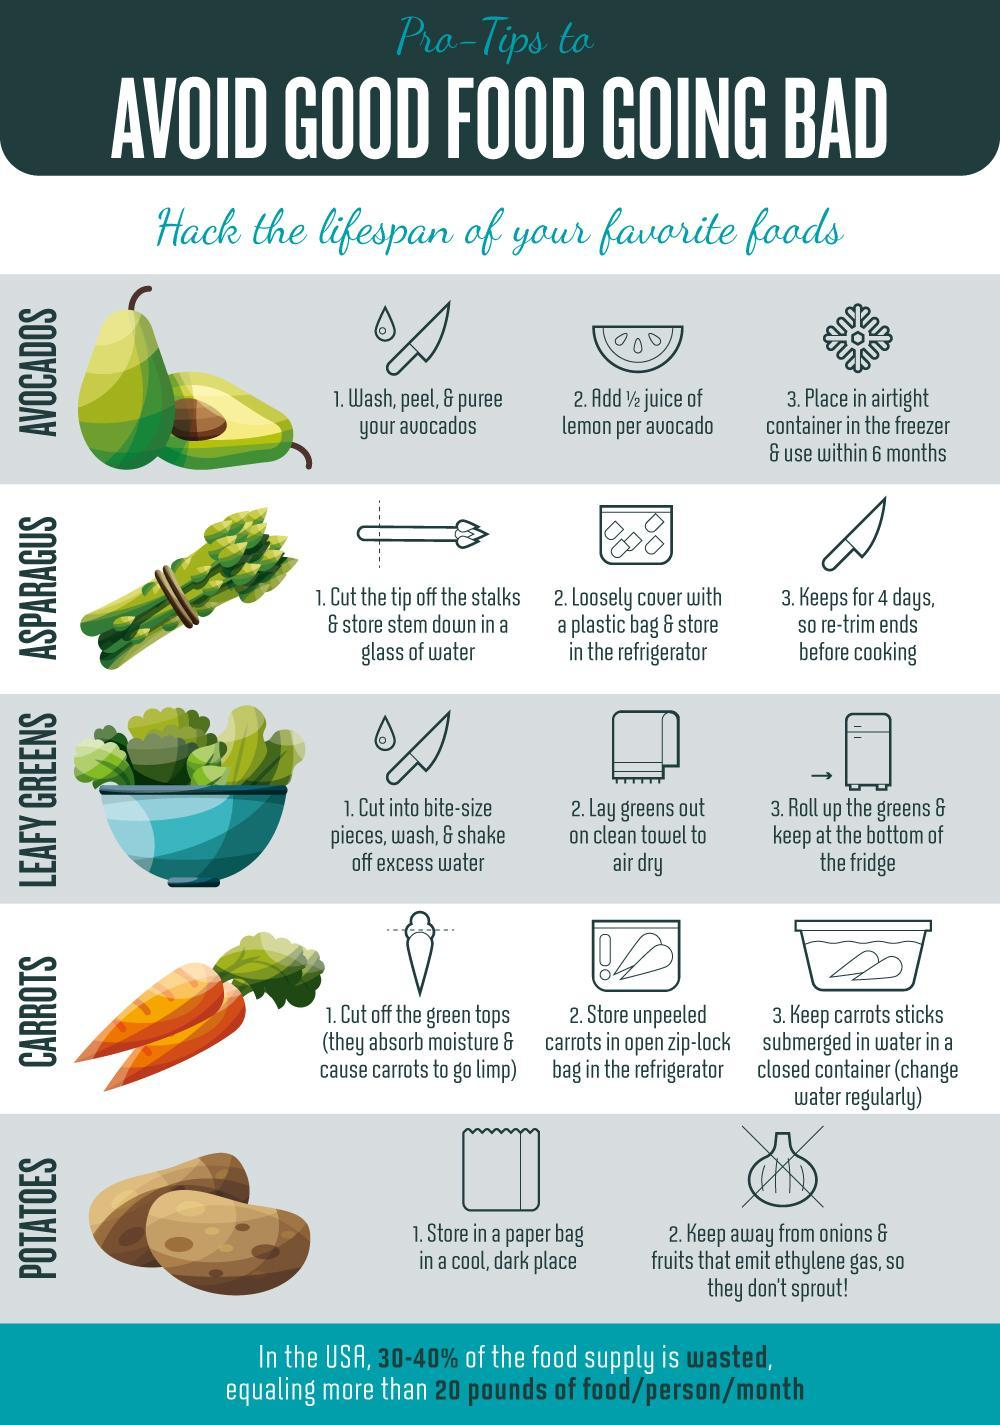Which part of of the carrots should be removed?
Answer the question with a short phrase. The green tops Which of these foods is a fruit? Avocados What is released from the onions that cause the potatoes to sprout? Ethylene gas How long can frozen avocados be stored? 6 months How many food items are shown here? 5 How long can you store asparagus in a glass of water? 4 days Which of the foods can be stored as a Puree? Avocados Which vegetables should be cut into bits before storing? Leafy greens How do you dry the leafy greens? Lay greens out on a clean towel to air dry Which vegetable shouldn't be stored with onions? Potatoes How should carrot sticks be stored? Keep carrot sticks submerged in water in a closed container How do you store unpeeled carrots? Store unpeeled carrots in open zip-lock bag in the refrigerator 